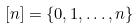Convert formula to latex. <formula><loc_0><loc_0><loc_500><loc_500>[ n ] = \{ 0 , 1 , \dots , n \}</formula> 